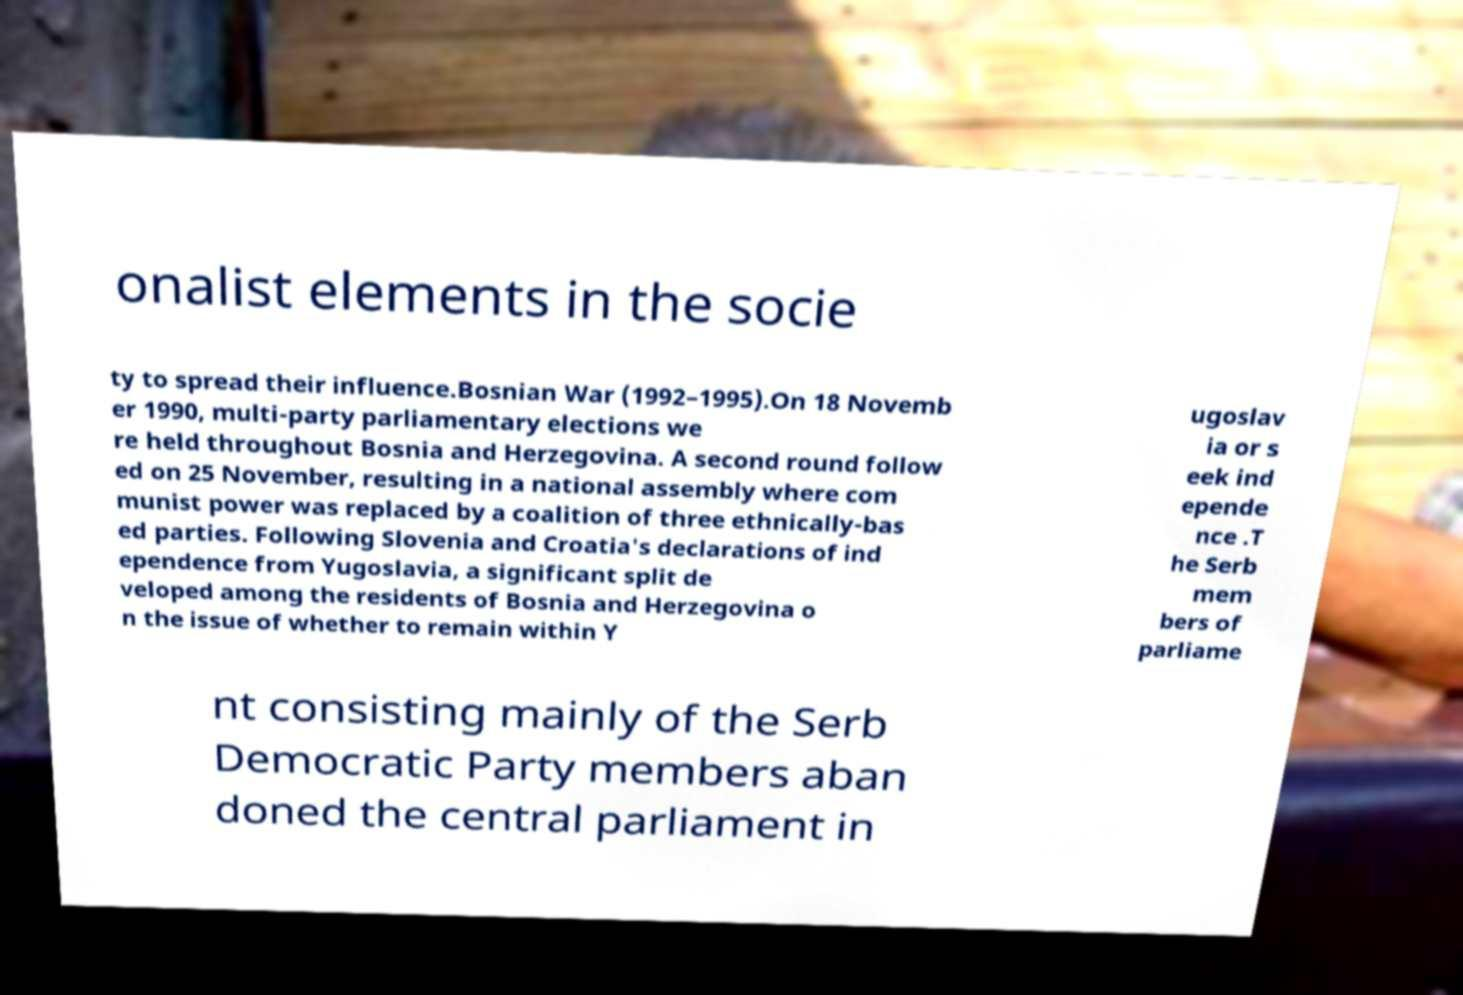Can you accurately transcribe the text from the provided image for me? onalist elements in the socie ty to spread their influence.Bosnian War (1992–1995).On 18 Novemb er 1990, multi-party parliamentary elections we re held throughout Bosnia and Herzegovina. A second round follow ed on 25 November, resulting in a national assembly where com munist power was replaced by a coalition of three ethnically-bas ed parties. Following Slovenia and Croatia's declarations of ind ependence from Yugoslavia, a significant split de veloped among the residents of Bosnia and Herzegovina o n the issue of whether to remain within Y ugoslav ia or s eek ind epende nce .T he Serb mem bers of parliame nt consisting mainly of the Serb Democratic Party members aban doned the central parliament in 